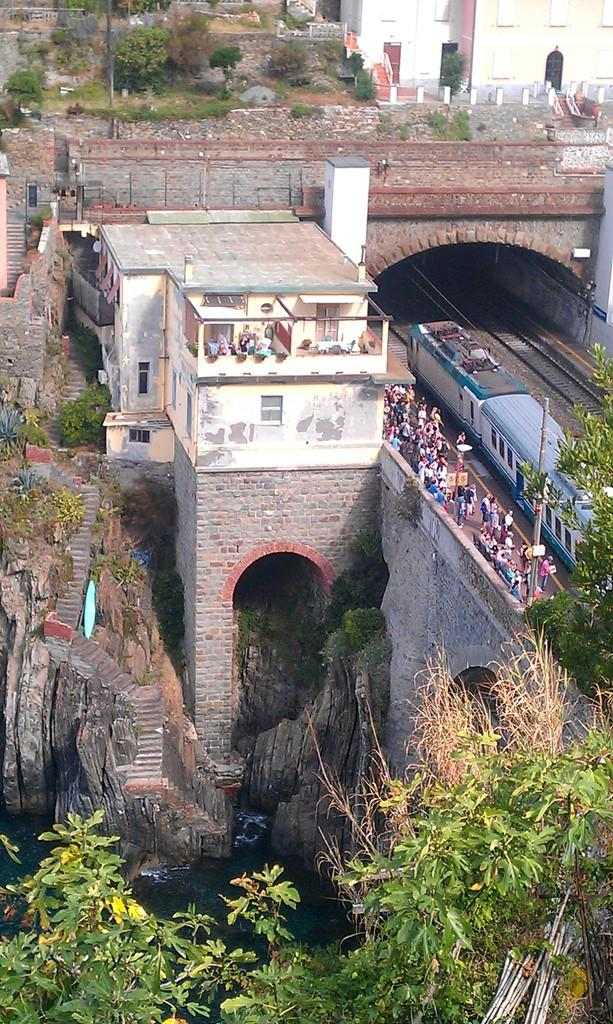What is the main subject of the image? The main subject of the image is a train. What can be observed about the train's location? The train is on tracks. Are there any people present in the image? Yes, there are people near the train. What type of natural elements can be seen in the image? There are trees and water visible in the image. What type of man-made structures are present in the image? There are buildings in the image. What type of collar can be seen on the train in the image? There is no collar present on the train in the image; it is a mode of transportation and not an animal. 